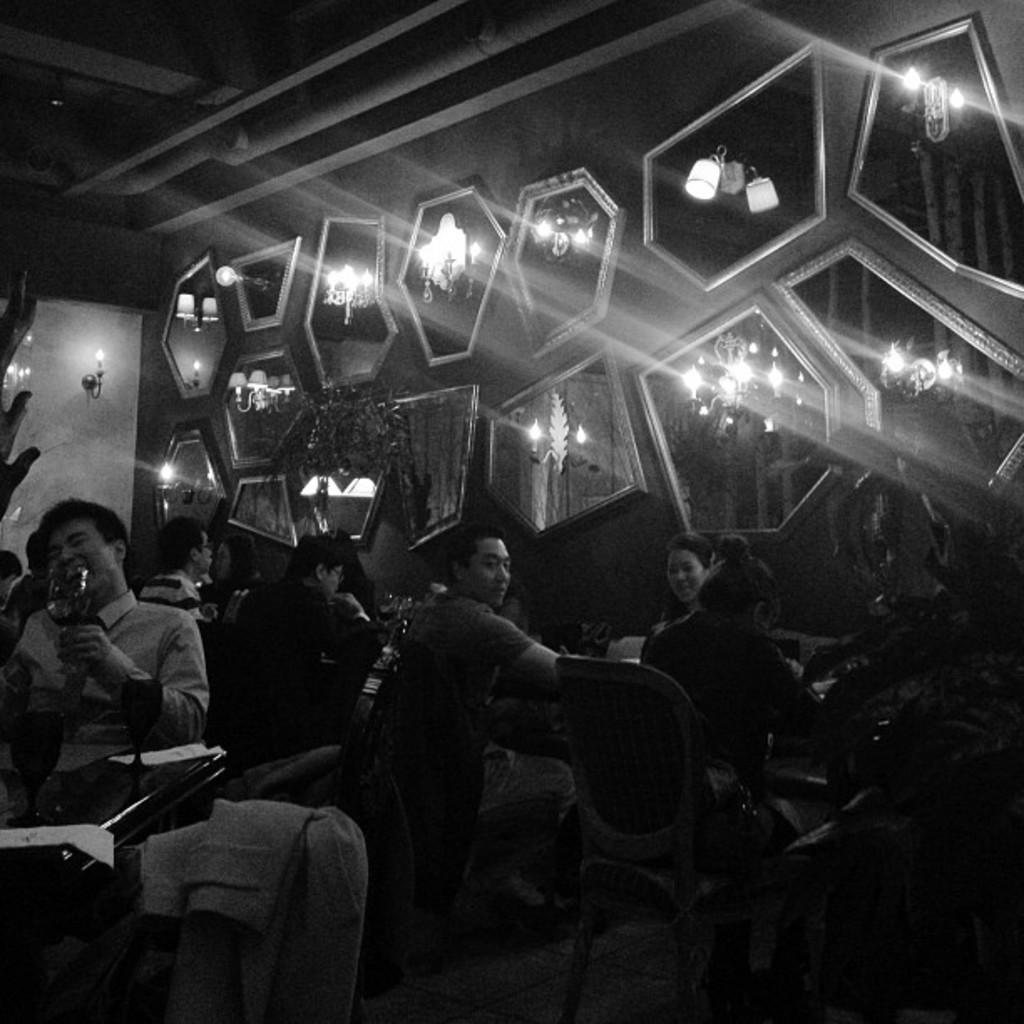What is the color scheme of the image? The image is black and white. What are the people in the image doing? The people in the image are sitting on chairs. What is in front of the people sitting on chairs? There is a table in front of the people sitting on chairs. What are some people holding in the image? Some people are holding a glass of drink in the image. What type of vegetable is being used as a shock absorber in the image? There is no vegetable or shock absorber present in the image. What type of station is visible in the background of the image? There is no station visible in the image; it only features people sitting on chairs, a table, and a glass of drink. 